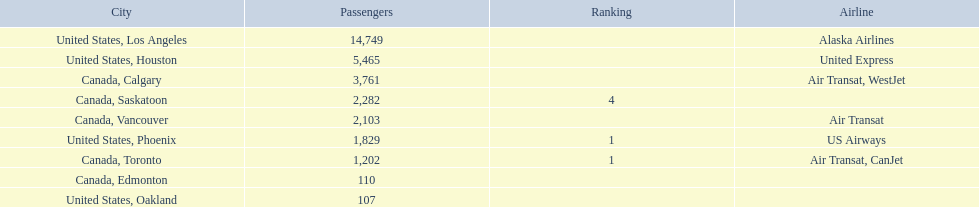What numbers are in the passengers column? 14,749, 5,465, 3,761, 2,282, 2,103, 1,829, 1,202, 110, 107. Which number is the lowest number in the passengers column? 107. What city is associated with this number? United States, Oakland. 